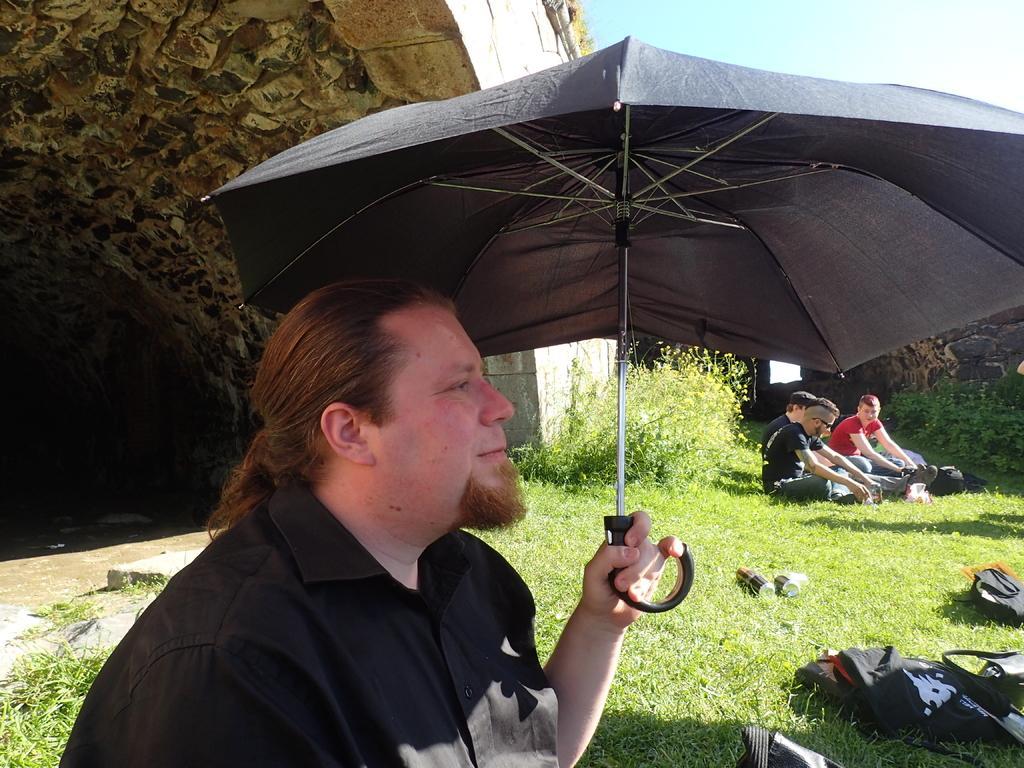Could you give a brief overview of what you see in this image? In this picture we can see some people sitting here, a man in the front is holding an umbrella, at the bottom there is grass, we can see the sky at the top of the picture, we can see this here, there is a bag here. 